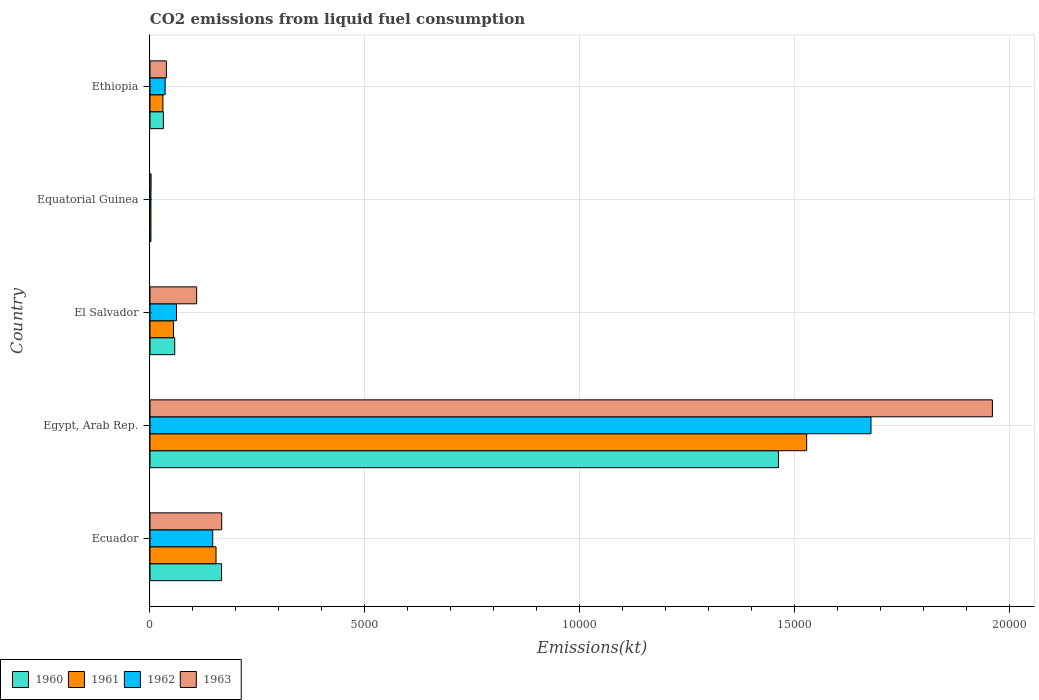How many different coloured bars are there?
Your answer should be very brief. 4. Are the number of bars per tick equal to the number of legend labels?
Offer a terse response. Yes. How many bars are there on the 2nd tick from the top?
Provide a short and direct response. 4. How many bars are there on the 4th tick from the bottom?
Make the answer very short. 4. What is the label of the 5th group of bars from the top?
Your answer should be compact. Ecuador. What is the amount of CO2 emitted in 1963 in Ecuador?
Your answer should be very brief. 1668.48. Across all countries, what is the maximum amount of CO2 emitted in 1962?
Keep it short and to the point. 1.68e+04. Across all countries, what is the minimum amount of CO2 emitted in 1960?
Make the answer very short. 22. In which country was the amount of CO2 emitted in 1963 maximum?
Provide a short and direct response. Egypt, Arab Rep. In which country was the amount of CO2 emitted in 1962 minimum?
Ensure brevity in your answer.  Equatorial Guinea. What is the total amount of CO2 emitted in 1960 in the graph?
Give a very brief answer. 1.72e+04. What is the difference between the amount of CO2 emitted in 1960 in Egypt, Arab Rep. and that in El Salvador?
Keep it short and to the point. 1.40e+04. What is the difference between the amount of CO2 emitted in 1963 in Ecuador and the amount of CO2 emitted in 1961 in El Salvador?
Offer a terse response. 1122.1. What is the average amount of CO2 emitted in 1961 per country?
Your answer should be very brief. 3536.45. What is the difference between the amount of CO2 emitted in 1960 and amount of CO2 emitted in 1961 in Ecuador?
Keep it short and to the point. 128.35. What is the ratio of the amount of CO2 emitted in 1962 in Ecuador to that in Ethiopia?
Make the answer very short. 4.15. What is the difference between the highest and the second highest amount of CO2 emitted in 1960?
Give a very brief answer. 1.30e+04. What is the difference between the highest and the lowest amount of CO2 emitted in 1960?
Your answer should be compact. 1.46e+04. In how many countries, is the amount of CO2 emitted in 1962 greater than the average amount of CO2 emitted in 1962 taken over all countries?
Offer a terse response. 1. Is the sum of the amount of CO2 emitted in 1960 in Equatorial Guinea and Ethiopia greater than the maximum amount of CO2 emitted in 1963 across all countries?
Offer a terse response. No. What does the 4th bar from the bottom in Ecuador represents?
Offer a very short reply. 1963. How many bars are there?
Make the answer very short. 20. Are all the bars in the graph horizontal?
Offer a terse response. Yes. How many countries are there in the graph?
Keep it short and to the point. 5. Are the values on the major ticks of X-axis written in scientific E-notation?
Give a very brief answer. No. How are the legend labels stacked?
Ensure brevity in your answer.  Horizontal. What is the title of the graph?
Keep it short and to the point. CO2 emissions from liquid fuel consumption. Does "1989" appear as one of the legend labels in the graph?
Make the answer very short. No. What is the label or title of the X-axis?
Provide a succinct answer. Emissions(kt). What is the Emissions(kt) in 1960 in Ecuador?
Offer a very short reply. 1664.82. What is the Emissions(kt) of 1961 in Ecuador?
Ensure brevity in your answer.  1536.47. What is the Emissions(kt) of 1962 in Ecuador?
Your answer should be compact. 1459.47. What is the Emissions(kt) of 1963 in Ecuador?
Your answer should be compact. 1668.48. What is the Emissions(kt) in 1960 in Egypt, Arab Rep.?
Offer a very short reply. 1.46e+04. What is the Emissions(kt) in 1961 in Egypt, Arab Rep.?
Your response must be concise. 1.53e+04. What is the Emissions(kt) in 1962 in Egypt, Arab Rep.?
Offer a very short reply. 1.68e+04. What is the Emissions(kt) in 1963 in Egypt, Arab Rep.?
Keep it short and to the point. 1.96e+04. What is the Emissions(kt) in 1960 in El Salvador?
Provide a succinct answer. 575.72. What is the Emissions(kt) of 1961 in El Salvador?
Your answer should be compact. 546.38. What is the Emissions(kt) in 1962 in El Salvador?
Give a very brief answer. 616.06. What is the Emissions(kt) in 1963 in El Salvador?
Make the answer very short. 1085.43. What is the Emissions(kt) in 1960 in Equatorial Guinea?
Make the answer very short. 22. What is the Emissions(kt) in 1961 in Equatorial Guinea?
Your answer should be compact. 22. What is the Emissions(kt) of 1962 in Equatorial Guinea?
Provide a succinct answer. 22. What is the Emissions(kt) in 1963 in Equatorial Guinea?
Offer a very short reply. 25.67. What is the Emissions(kt) of 1960 in Ethiopia?
Your response must be concise. 311.69. What is the Emissions(kt) in 1961 in Ethiopia?
Your answer should be compact. 300.69. What is the Emissions(kt) of 1962 in Ethiopia?
Ensure brevity in your answer.  352.03. What is the Emissions(kt) of 1963 in Ethiopia?
Your answer should be very brief. 381.37. Across all countries, what is the maximum Emissions(kt) of 1960?
Make the answer very short. 1.46e+04. Across all countries, what is the maximum Emissions(kt) in 1961?
Ensure brevity in your answer.  1.53e+04. Across all countries, what is the maximum Emissions(kt) of 1962?
Your answer should be very brief. 1.68e+04. Across all countries, what is the maximum Emissions(kt) in 1963?
Your answer should be compact. 1.96e+04. Across all countries, what is the minimum Emissions(kt) of 1960?
Your answer should be compact. 22. Across all countries, what is the minimum Emissions(kt) in 1961?
Give a very brief answer. 22. Across all countries, what is the minimum Emissions(kt) of 1962?
Your answer should be compact. 22. Across all countries, what is the minimum Emissions(kt) in 1963?
Offer a very short reply. 25.67. What is the total Emissions(kt) of 1960 in the graph?
Provide a short and direct response. 1.72e+04. What is the total Emissions(kt) in 1961 in the graph?
Offer a terse response. 1.77e+04. What is the total Emissions(kt) in 1962 in the graph?
Keep it short and to the point. 1.92e+04. What is the total Emissions(kt) of 1963 in the graph?
Give a very brief answer. 2.28e+04. What is the difference between the Emissions(kt) in 1960 in Ecuador and that in Egypt, Arab Rep.?
Your answer should be very brief. -1.30e+04. What is the difference between the Emissions(kt) of 1961 in Ecuador and that in Egypt, Arab Rep.?
Your answer should be compact. -1.37e+04. What is the difference between the Emissions(kt) of 1962 in Ecuador and that in Egypt, Arab Rep.?
Offer a terse response. -1.53e+04. What is the difference between the Emissions(kt) of 1963 in Ecuador and that in Egypt, Arab Rep.?
Your answer should be very brief. -1.79e+04. What is the difference between the Emissions(kt) of 1960 in Ecuador and that in El Salvador?
Offer a terse response. 1089.1. What is the difference between the Emissions(kt) in 1961 in Ecuador and that in El Salvador?
Give a very brief answer. 990.09. What is the difference between the Emissions(kt) in 1962 in Ecuador and that in El Salvador?
Provide a succinct answer. 843.41. What is the difference between the Emissions(kt) of 1963 in Ecuador and that in El Salvador?
Your answer should be compact. 583.05. What is the difference between the Emissions(kt) in 1960 in Ecuador and that in Equatorial Guinea?
Your response must be concise. 1642.82. What is the difference between the Emissions(kt) of 1961 in Ecuador and that in Equatorial Guinea?
Give a very brief answer. 1514.47. What is the difference between the Emissions(kt) of 1962 in Ecuador and that in Equatorial Guinea?
Provide a short and direct response. 1437.46. What is the difference between the Emissions(kt) of 1963 in Ecuador and that in Equatorial Guinea?
Ensure brevity in your answer.  1642.82. What is the difference between the Emissions(kt) of 1960 in Ecuador and that in Ethiopia?
Provide a short and direct response. 1353.12. What is the difference between the Emissions(kt) of 1961 in Ecuador and that in Ethiopia?
Give a very brief answer. 1235.78. What is the difference between the Emissions(kt) of 1962 in Ecuador and that in Ethiopia?
Your response must be concise. 1107.43. What is the difference between the Emissions(kt) of 1963 in Ecuador and that in Ethiopia?
Your answer should be compact. 1287.12. What is the difference between the Emissions(kt) in 1960 in Egypt, Arab Rep. and that in El Salvador?
Your answer should be very brief. 1.40e+04. What is the difference between the Emissions(kt) in 1961 in Egypt, Arab Rep. and that in El Salvador?
Your answer should be compact. 1.47e+04. What is the difference between the Emissions(kt) of 1962 in Egypt, Arab Rep. and that in El Salvador?
Give a very brief answer. 1.62e+04. What is the difference between the Emissions(kt) of 1963 in Egypt, Arab Rep. and that in El Salvador?
Offer a terse response. 1.85e+04. What is the difference between the Emissions(kt) of 1960 in Egypt, Arab Rep. and that in Equatorial Guinea?
Provide a succinct answer. 1.46e+04. What is the difference between the Emissions(kt) of 1961 in Egypt, Arab Rep. and that in Equatorial Guinea?
Your answer should be very brief. 1.53e+04. What is the difference between the Emissions(kt) in 1962 in Egypt, Arab Rep. and that in Equatorial Guinea?
Your response must be concise. 1.68e+04. What is the difference between the Emissions(kt) of 1963 in Egypt, Arab Rep. and that in Equatorial Guinea?
Make the answer very short. 1.96e+04. What is the difference between the Emissions(kt) of 1960 in Egypt, Arab Rep. and that in Ethiopia?
Offer a very short reply. 1.43e+04. What is the difference between the Emissions(kt) of 1961 in Egypt, Arab Rep. and that in Ethiopia?
Offer a very short reply. 1.50e+04. What is the difference between the Emissions(kt) in 1962 in Egypt, Arab Rep. and that in Ethiopia?
Keep it short and to the point. 1.64e+04. What is the difference between the Emissions(kt) in 1963 in Egypt, Arab Rep. and that in Ethiopia?
Ensure brevity in your answer.  1.92e+04. What is the difference between the Emissions(kt) of 1960 in El Salvador and that in Equatorial Guinea?
Offer a very short reply. 553.72. What is the difference between the Emissions(kt) of 1961 in El Salvador and that in Equatorial Guinea?
Make the answer very short. 524.38. What is the difference between the Emissions(kt) in 1962 in El Salvador and that in Equatorial Guinea?
Offer a very short reply. 594.05. What is the difference between the Emissions(kt) in 1963 in El Salvador and that in Equatorial Guinea?
Your answer should be compact. 1059.76. What is the difference between the Emissions(kt) in 1960 in El Salvador and that in Ethiopia?
Make the answer very short. 264.02. What is the difference between the Emissions(kt) in 1961 in El Salvador and that in Ethiopia?
Ensure brevity in your answer.  245.69. What is the difference between the Emissions(kt) of 1962 in El Salvador and that in Ethiopia?
Provide a short and direct response. 264.02. What is the difference between the Emissions(kt) of 1963 in El Salvador and that in Ethiopia?
Make the answer very short. 704.06. What is the difference between the Emissions(kt) of 1960 in Equatorial Guinea and that in Ethiopia?
Ensure brevity in your answer.  -289.69. What is the difference between the Emissions(kt) of 1961 in Equatorial Guinea and that in Ethiopia?
Ensure brevity in your answer.  -278.69. What is the difference between the Emissions(kt) of 1962 in Equatorial Guinea and that in Ethiopia?
Offer a very short reply. -330.03. What is the difference between the Emissions(kt) of 1963 in Equatorial Guinea and that in Ethiopia?
Offer a terse response. -355.7. What is the difference between the Emissions(kt) in 1960 in Ecuador and the Emissions(kt) in 1961 in Egypt, Arab Rep.?
Your answer should be compact. -1.36e+04. What is the difference between the Emissions(kt) in 1960 in Ecuador and the Emissions(kt) in 1962 in Egypt, Arab Rep.?
Make the answer very short. -1.51e+04. What is the difference between the Emissions(kt) in 1960 in Ecuador and the Emissions(kt) in 1963 in Egypt, Arab Rep.?
Ensure brevity in your answer.  -1.79e+04. What is the difference between the Emissions(kt) in 1961 in Ecuador and the Emissions(kt) in 1962 in Egypt, Arab Rep.?
Provide a succinct answer. -1.52e+04. What is the difference between the Emissions(kt) of 1961 in Ecuador and the Emissions(kt) of 1963 in Egypt, Arab Rep.?
Offer a very short reply. -1.81e+04. What is the difference between the Emissions(kt) of 1962 in Ecuador and the Emissions(kt) of 1963 in Egypt, Arab Rep.?
Make the answer very short. -1.81e+04. What is the difference between the Emissions(kt) of 1960 in Ecuador and the Emissions(kt) of 1961 in El Salvador?
Provide a succinct answer. 1118.43. What is the difference between the Emissions(kt) of 1960 in Ecuador and the Emissions(kt) of 1962 in El Salvador?
Make the answer very short. 1048.76. What is the difference between the Emissions(kt) of 1960 in Ecuador and the Emissions(kt) of 1963 in El Salvador?
Offer a very short reply. 579.39. What is the difference between the Emissions(kt) in 1961 in Ecuador and the Emissions(kt) in 1962 in El Salvador?
Keep it short and to the point. 920.42. What is the difference between the Emissions(kt) of 1961 in Ecuador and the Emissions(kt) of 1963 in El Salvador?
Offer a terse response. 451.04. What is the difference between the Emissions(kt) of 1962 in Ecuador and the Emissions(kt) of 1963 in El Salvador?
Make the answer very short. 374.03. What is the difference between the Emissions(kt) in 1960 in Ecuador and the Emissions(kt) in 1961 in Equatorial Guinea?
Keep it short and to the point. 1642.82. What is the difference between the Emissions(kt) in 1960 in Ecuador and the Emissions(kt) in 1962 in Equatorial Guinea?
Your response must be concise. 1642.82. What is the difference between the Emissions(kt) in 1960 in Ecuador and the Emissions(kt) in 1963 in Equatorial Guinea?
Give a very brief answer. 1639.15. What is the difference between the Emissions(kt) of 1961 in Ecuador and the Emissions(kt) of 1962 in Equatorial Guinea?
Your answer should be very brief. 1514.47. What is the difference between the Emissions(kt) in 1961 in Ecuador and the Emissions(kt) in 1963 in Equatorial Guinea?
Your answer should be compact. 1510.8. What is the difference between the Emissions(kt) in 1962 in Ecuador and the Emissions(kt) in 1963 in Equatorial Guinea?
Your answer should be compact. 1433.8. What is the difference between the Emissions(kt) of 1960 in Ecuador and the Emissions(kt) of 1961 in Ethiopia?
Make the answer very short. 1364.12. What is the difference between the Emissions(kt) of 1960 in Ecuador and the Emissions(kt) of 1962 in Ethiopia?
Provide a succinct answer. 1312.79. What is the difference between the Emissions(kt) of 1960 in Ecuador and the Emissions(kt) of 1963 in Ethiopia?
Keep it short and to the point. 1283.45. What is the difference between the Emissions(kt) of 1961 in Ecuador and the Emissions(kt) of 1962 in Ethiopia?
Your response must be concise. 1184.44. What is the difference between the Emissions(kt) of 1961 in Ecuador and the Emissions(kt) of 1963 in Ethiopia?
Offer a terse response. 1155.11. What is the difference between the Emissions(kt) of 1962 in Ecuador and the Emissions(kt) of 1963 in Ethiopia?
Offer a terse response. 1078.1. What is the difference between the Emissions(kt) in 1960 in Egypt, Arab Rep. and the Emissions(kt) in 1961 in El Salvador?
Give a very brief answer. 1.41e+04. What is the difference between the Emissions(kt) in 1960 in Egypt, Arab Rep. and the Emissions(kt) in 1962 in El Salvador?
Provide a succinct answer. 1.40e+04. What is the difference between the Emissions(kt) of 1960 in Egypt, Arab Rep. and the Emissions(kt) of 1963 in El Salvador?
Your answer should be compact. 1.35e+04. What is the difference between the Emissions(kt) of 1961 in Egypt, Arab Rep. and the Emissions(kt) of 1962 in El Salvador?
Offer a very short reply. 1.47e+04. What is the difference between the Emissions(kt) of 1961 in Egypt, Arab Rep. and the Emissions(kt) of 1963 in El Salvador?
Provide a succinct answer. 1.42e+04. What is the difference between the Emissions(kt) of 1962 in Egypt, Arab Rep. and the Emissions(kt) of 1963 in El Salvador?
Provide a short and direct response. 1.57e+04. What is the difference between the Emissions(kt) of 1960 in Egypt, Arab Rep. and the Emissions(kt) of 1961 in Equatorial Guinea?
Your answer should be compact. 1.46e+04. What is the difference between the Emissions(kt) of 1960 in Egypt, Arab Rep. and the Emissions(kt) of 1962 in Equatorial Guinea?
Keep it short and to the point. 1.46e+04. What is the difference between the Emissions(kt) of 1960 in Egypt, Arab Rep. and the Emissions(kt) of 1963 in Equatorial Guinea?
Provide a short and direct response. 1.46e+04. What is the difference between the Emissions(kt) of 1961 in Egypt, Arab Rep. and the Emissions(kt) of 1962 in Equatorial Guinea?
Your answer should be very brief. 1.53e+04. What is the difference between the Emissions(kt) of 1961 in Egypt, Arab Rep. and the Emissions(kt) of 1963 in Equatorial Guinea?
Offer a terse response. 1.53e+04. What is the difference between the Emissions(kt) in 1962 in Egypt, Arab Rep. and the Emissions(kt) in 1963 in Equatorial Guinea?
Keep it short and to the point. 1.67e+04. What is the difference between the Emissions(kt) in 1960 in Egypt, Arab Rep. and the Emissions(kt) in 1961 in Ethiopia?
Ensure brevity in your answer.  1.43e+04. What is the difference between the Emissions(kt) of 1960 in Egypt, Arab Rep. and the Emissions(kt) of 1962 in Ethiopia?
Offer a very short reply. 1.43e+04. What is the difference between the Emissions(kt) of 1960 in Egypt, Arab Rep. and the Emissions(kt) of 1963 in Ethiopia?
Offer a terse response. 1.42e+04. What is the difference between the Emissions(kt) of 1961 in Egypt, Arab Rep. and the Emissions(kt) of 1962 in Ethiopia?
Your answer should be very brief. 1.49e+04. What is the difference between the Emissions(kt) in 1961 in Egypt, Arab Rep. and the Emissions(kt) in 1963 in Ethiopia?
Offer a very short reply. 1.49e+04. What is the difference between the Emissions(kt) of 1962 in Egypt, Arab Rep. and the Emissions(kt) of 1963 in Ethiopia?
Make the answer very short. 1.64e+04. What is the difference between the Emissions(kt) of 1960 in El Salvador and the Emissions(kt) of 1961 in Equatorial Guinea?
Offer a terse response. 553.72. What is the difference between the Emissions(kt) in 1960 in El Salvador and the Emissions(kt) in 1962 in Equatorial Guinea?
Provide a succinct answer. 553.72. What is the difference between the Emissions(kt) of 1960 in El Salvador and the Emissions(kt) of 1963 in Equatorial Guinea?
Offer a terse response. 550.05. What is the difference between the Emissions(kt) of 1961 in El Salvador and the Emissions(kt) of 1962 in Equatorial Guinea?
Keep it short and to the point. 524.38. What is the difference between the Emissions(kt) in 1961 in El Salvador and the Emissions(kt) in 1963 in Equatorial Guinea?
Ensure brevity in your answer.  520.71. What is the difference between the Emissions(kt) in 1962 in El Salvador and the Emissions(kt) in 1963 in Equatorial Guinea?
Keep it short and to the point. 590.39. What is the difference between the Emissions(kt) of 1960 in El Salvador and the Emissions(kt) of 1961 in Ethiopia?
Keep it short and to the point. 275.02. What is the difference between the Emissions(kt) of 1960 in El Salvador and the Emissions(kt) of 1962 in Ethiopia?
Provide a succinct answer. 223.69. What is the difference between the Emissions(kt) in 1960 in El Salvador and the Emissions(kt) in 1963 in Ethiopia?
Your response must be concise. 194.35. What is the difference between the Emissions(kt) in 1961 in El Salvador and the Emissions(kt) in 1962 in Ethiopia?
Give a very brief answer. 194.35. What is the difference between the Emissions(kt) of 1961 in El Salvador and the Emissions(kt) of 1963 in Ethiopia?
Make the answer very short. 165.01. What is the difference between the Emissions(kt) in 1962 in El Salvador and the Emissions(kt) in 1963 in Ethiopia?
Keep it short and to the point. 234.69. What is the difference between the Emissions(kt) in 1960 in Equatorial Guinea and the Emissions(kt) in 1961 in Ethiopia?
Provide a succinct answer. -278.69. What is the difference between the Emissions(kt) of 1960 in Equatorial Guinea and the Emissions(kt) of 1962 in Ethiopia?
Provide a short and direct response. -330.03. What is the difference between the Emissions(kt) in 1960 in Equatorial Guinea and the Emissions(kt) in 1963 in Ethiopia?
Offer a terse response. -359.37. What is the difference between the Emissions(kt) of 1961 in Equatorial Guinea and the Emissions(kt) of 1962 in Ethiopia?
Ensure brevity in your answer.  -330.03. What is the difference between the Emissions(kt) of 1961 in Equatorial Guinea and the Emissions(kt) of 1963 in Ethiopia?
Provide a short and direct response. -359.37. What is the difference between the Emissions(kt) in 1962 in Equatorial Guinea and the Emissions(kt) in 1963 in Ethiopia?
Ensure brevity in your answer.  -359.37. What is the average Emissions(kt) in 1960 per country?
Keep it short and to the point. 3438.91. What is the average Emissions(kt) in 1961 per country?
Offer a terse response. 3536.45. What is the average Emissions(kt) in 1962 per country?
Offer a terse response. 3844.48. What is the average Emissions(kt) of 1963 per country?
Ensure brevity in your answer.  4551.48. What is the difference between the Emissions(kt) of 1960 and Emissions(kt) of 1961 in Ecuador?
Your answer should be compact. 128.34. What is the difference between the Emissions(kt) in 1960 and Emissions(kt) in 1962 in Ecuador?
Your answer should be very brief. 205.35. What is the difference between the Emissions(kt) in 1960 and Emissions(kt) in 1963 in Ecuador?
Offer a terse response. -3.67. What is the difference between the Emissions(kt) in 1961 and Emissions(kt) in 1962 in Ecuador?
Make the answer very short. 77.01. What is the difference between the Emissions(kt) of 1961 and Emissions(kt) of 1963 in Ecuador?
Keep it short and to the point. -132.01. What is the difference between the Emissions(kt) in 1962 and Emissions(kt) in 1963 in Ecuador?
Provide a succinct answer. -209.02. What is the difference between the Emissions(kt) of 1960 and Emissions(kt) of 1961 in Egypt, Arab Rep.?
Offer a very short reply. -656.39. What is the difference between the Emissions(kt) in 1960 and Emissions(kt) in 1962 in Egypt, Arab Rep.?
Offer a terse response. -2152.53. What is the difference between the Emissions(kt) in 1960 and Emissions(kt) in 1963 in Egypt, Arab Rep.?
Offer a very short reply. -4976.12. What is the difference between the Emissions(kt) in 1961 and Emissions(kt) in 1962 in Egypt, Arab Rep.?
Offer a terse response. -1496.14. What is the difference between the Emissions(kt) in 1961 and Emissions(kt) in 1963 in Egypt, Arab Rep.?
Your response must be concise. -4319.73. What is the difference between the Emissions(kt) of 1962 and Emissions(kt) of 1963 in Egypt, Arab Rep.?
Your answer should be very brief. -2823.59. What is the difference between the Emissions(kt) in 1960 and Emissions(kt) in 1961 in El Salvador?
Provide a succinct answer. 29.34. What is the difference between the Emissions(kt) in 1960 and Emissions(kt) in 1962 in El Salvador?
Your response must be concise. -40.34. What is the difference between the Emissions(kt) in 1960 and Emissions(kt) in 1963 in El Salvador?
Your answer should be very brief. -509.71. What is the difference between the Emissions(kt) in 1961 and Emissions(kt) in 1962 in El Salvador?
Your answer should be very brief. -69.67. What is the difference between the Emissions(kt) in 1961 and Emissions(kt) in 1963 in El Salvador?
Give a very brief answer. -539.05. What is the difference between the Emissions(kt) of 1962 and Emissions(kt) of 1963 in El Salvador?
Offer a very short reply. -469.38. What is the difference between the Emissions(kt) in 1960 and Emissions(kt) in 1963 in Equatorial Guinea?
Your answer should be compact. -3.67. What is the difference between the Emissions(kt) in 1961 and Emissions(kt) in 1963 in Equatorial Guinea?
Keep it short and to the point. -3.67. What is the difference between the Emissions(kt) in 1962 and Emissions(kt) in 1963 in Equatorial Guinea?
Make the answer very short. -3.67. What is the difference between the Emissions(kt) in 1960 and Emissions(kt) in 1961 in Ethiopia?
Offer a terse response. 11. What is the difference between the Emissions(kt) of 1960 and Emissions(kt) of 1962 in Ethiopia?
Keep it short and to the point. -40.34. What is the difference between the Emissions(kt) in 1960 and Emissions(kt) in 1963 in Ethiopia?
Make the answer very short. -69.67. What is the difference between the Emissions(kt) of 1961 and Emissions(kt) of 1962 in Ethiopia?
Make the answer very short. -51.34. What is the difference between the Emissions(kt) in 1961 and Emissions(kt) in 1963 in Ethiopia?
Offer a very short reply. -80.67. What is the difference between the Emissions(kt) of 1962 and Emissions(kt) of 1963 in Ethiopia?
Your answer should be compact. -29.34. What is the ratio of the Emissions(kt) of 1960 in Ecuador to that in Egypt, Arab Rep.?
Your answer should be very brief. 0.11. What is the ratio of the Emissions(kt) in 1961 in Ecuador to that in Egypt, Arab Rep.?
Make the answer very short. 0.1. What is the ratio of the Emissions(kt) in 1962 in Ecuador to that in Egypt, Arab Rep.?
Give a very brief answer. 0.09. What is the ratio of the Emissions(kt) in 1963 in Ecuador to that in Egypt, Arab Rep.?
Offer a terse response. 0.09. What is the ratio of the Emissions(kt) of 1960 in Ecuador to that in El Salvador?
Ensure brevity in your answer.  2.89. What is the ratio of the Emissions(kt) in 1961 in Ecuador to that in El Salvador?
Ensure brevity in your answer.  2.81. What is the ratio of the Emissions(kt) of 1962 in Ecuador to that in El Salvador?
Keep it short and to the point. 2.37. What is the ratio of the Emissions(kt) in 1963 in Ecuador to that in El Salvador?
Make the answer very short. 1.54. What is the ratio of the Emissions(kt) of 1960 in Ecuador to that in Equatorial Guinea?
Your answer should be compact. 75.67. What is the ratio of the Emissions(kt) in 1961 in Ecuador to that in Equatorial Guinea?
Ensure brevity in your answer.  69.83. What is the ratio of the Emissions(kt) in 1962 in Ecuador to that in Equatorial Guinea?
Your response must be concise. 66.33. What is the ratio of the Emissions(kt) of 1960 in Ecuador to that in Ethiopia?
Your answer should be very brief. 5.34. What is the ratio of the Emissions(kt) of 1961 in Ecuador to that in Ethiopia?
Provide a short and direct response. 5.11. What is the ratio of the Emissions(kt) of 1962 in Ecuador to that in Ethiopia?
Offer a very short reply. 4.15. What is the ratio of the Emissions(kt) in 1963 in Ecuador to that in Ethiopia?
Your response must be concise. 4.38. What is the ratio of the Emissions(kt) in 1960 in Egypt, Arab Rep. to that in El Salvador?
Give a very brief answer. 25.39. What is the ratio of the Emissions(kt) in 1961 in Egypt, Arab Rep. to that in El Salvador?
Keep it short and to the point. 27.96. What is the ratio of the Emissions(kt) of 1962 in Egypt, Arab Rep. to that in El Salvador?
Provide a succinct answer. 27.23. What is the ratio of the Emissions(kt) of 1963 in Egypt, Arab Rep. to that in El Salvador?
Your answer should be compact. 18.05. What is the ratio of the Emissions(kt) in 1960 in Egypt, Arab Rep. to that in Equatorial Guinea?
Ensure brevity in your answer.  664.5. What is the ratio of the Emissions(kt) in 1961 in Egypt, Arab Rep. to that in Equatorial Guinea?
Your answer should be compact. 694.33. What is the ratio of the Emissions(kt) in 1962 in Egypt, Arab Rep. to that in Equatorial Guinea?
Keep it short and to the point. 762.33. What is the ratio of the Emissions(kt) in 1963 in Egypt, Arab Rep. to that in Equatorial Guinea?
Your response must be concise. 763.43. What is the ratio of the Emissions(kt) of 1960 in Egypt, Arab Rep. to that in Ethiopia?
Provide a short and direct response. 46.91. What is the ratio of the Emissions(kt) in 1961 in Egypt, Arab Rep. to that in Ethiopia?
Your answer should be compact. 50.8. What is the ratio of the Emissions(kt) of 1962 in Egypt, Arab Rep. to that in Ethiopia?
Provide a short and direct response. 47.65. What is the ratio of the Emissions(kt) in 1963 in Egypt, Arab Rep. to that in Ethiopia?
Offer a very short reply. 51.38. What is the ratio of the Emissions(kt) of 1960 in El Salvador to that in Equatorial Guinea?
Give a very brief answer. 26.17. What is the ratio of the Emissions(kt) in 1961 in El Salvador to that in Equatorial Guinea?
Your response must be concise. 24.83. What is the ratio of the Emissions(kt) in 1962 in El Salvador to that in Equatorial Guinea?
Ensure brevity in your answer.  28. What is the ratio of the Emissions(kt) in 1963 in El Salvador to that in Equatorial Guinea?
Keep it short and to the point. 42.29. What is the ratio of the Emissions(kt) in 1960 in El Salvador to that in Ethiopia?
Offer a very short reply. 1.85. What is the ratio of the Emissions(kt) of 1961 in El Salvador to that in Ethiopia?
Make the answer very short. 1.82. What is the ratio of the Emissions(kt) of 1962 in El Salvador to that in Ethiopia?
Give a very brief answer. 1.75. What is the ratio of the Emissions(kt) in 1963 in El Salvador to that in Ethiopia?
Offer a very short reply. 2.85. What is the ratio of the Emissions(kt) in 1960 in Equatorial Guinea to that in Ethiopia?
Provide a succinct answer. 0.07. What is the ratio of the Emissions(kt) in 1961 in Equatorial Guinea to that in Ethiopia?
Provide a short and direct response. 0.07. What is the ratio of the Emissions(kt) in 1962 in Equatorial Guinea to that in Ethiopia?
Provide a short and direct response. 0.06. What is the ratio of the Emissions(kt) in 1963 in Equatorial Guinea to that in Ethiopia?
Your response must be concise. 0.07. What is the difference between the highest and the second highest Emissions(kt) in 1960?
Ensure brevity in your answer.  1.30e+04. What is the difference between the highest and the second highest Emissions(kt) of 1961?
Ensure brevity in your answer.  1.37e+04. What is the difference between the highest and the second highest Emissions(kt) in 1962?
Provide a short and direct response. 1.53e+04. What is the difference between the highest and the second highest Emissions(kt) of 1963?
Your answer should be compact. 1.79e+04. What is the difference between the highest and the lowest Emissions(kt) in 1960?
Ensure brevity in your answer.  1.46e+04. What is the difference between the highest and the lowest Emissions(kt) of 1961?
Your response must be concise. 1.53e+04. What is the difference between the highest and the lowest Emissions(kt) in 1962?
Offer a terse response. 1.68e+04. What is the difference between the highest and the lowest Emissions(kt) of 1963?
Ensure brevity in your answer.  1.96e+04. 